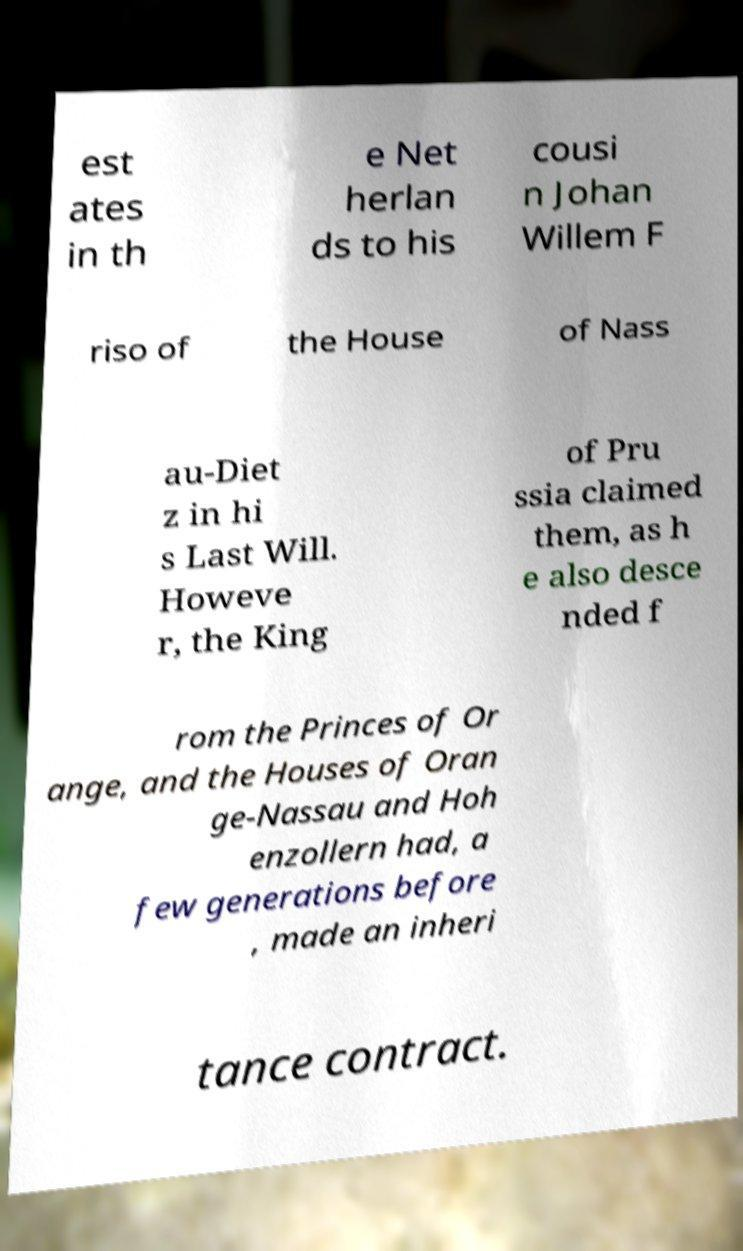Could you extract and type out the text from this image? est ates in th e Net herlan ds to his cousi n Johan Willem F riso of the House of Nass au-Diet z in hi s Last Will. Howeve r, the King of Pru ssia claimed them, as h e also desce nded f rom the Princes of Or ange, and the Houses of Oran ge-Nassau and Hoh enzollern had, a few generations before , made an inheri tance contract. 